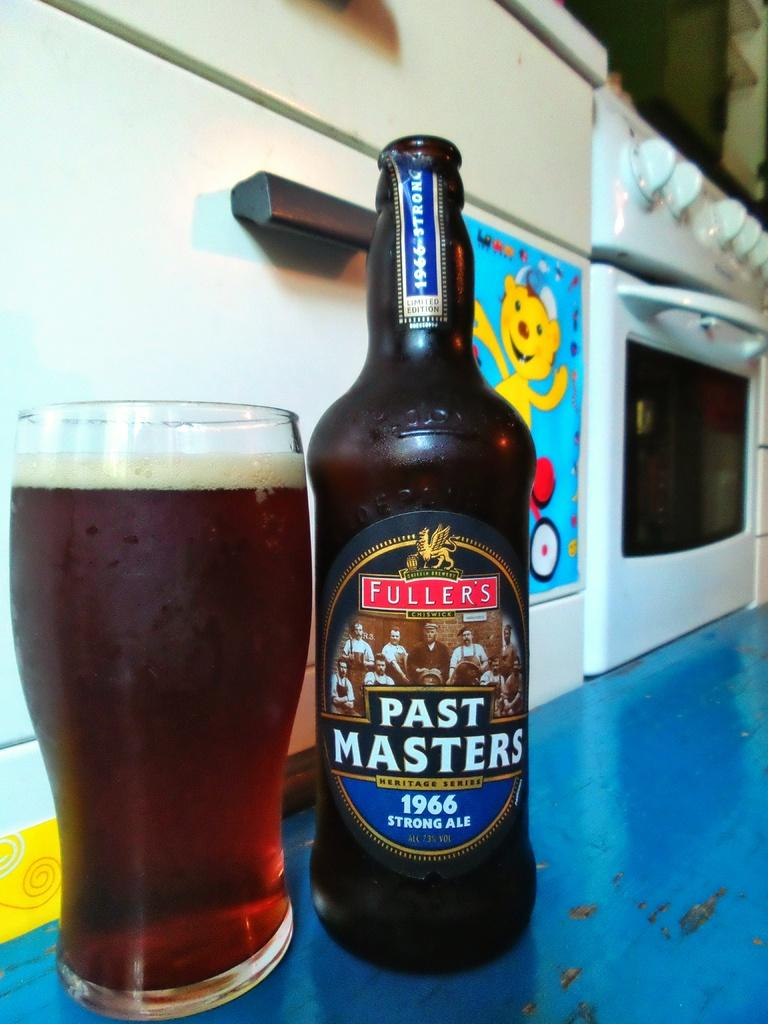<image>
Provide a brief description of the given image. A bottle reading "Past Masters 1966" standing next to a glass that appears to be filled with the bottle's contents. 